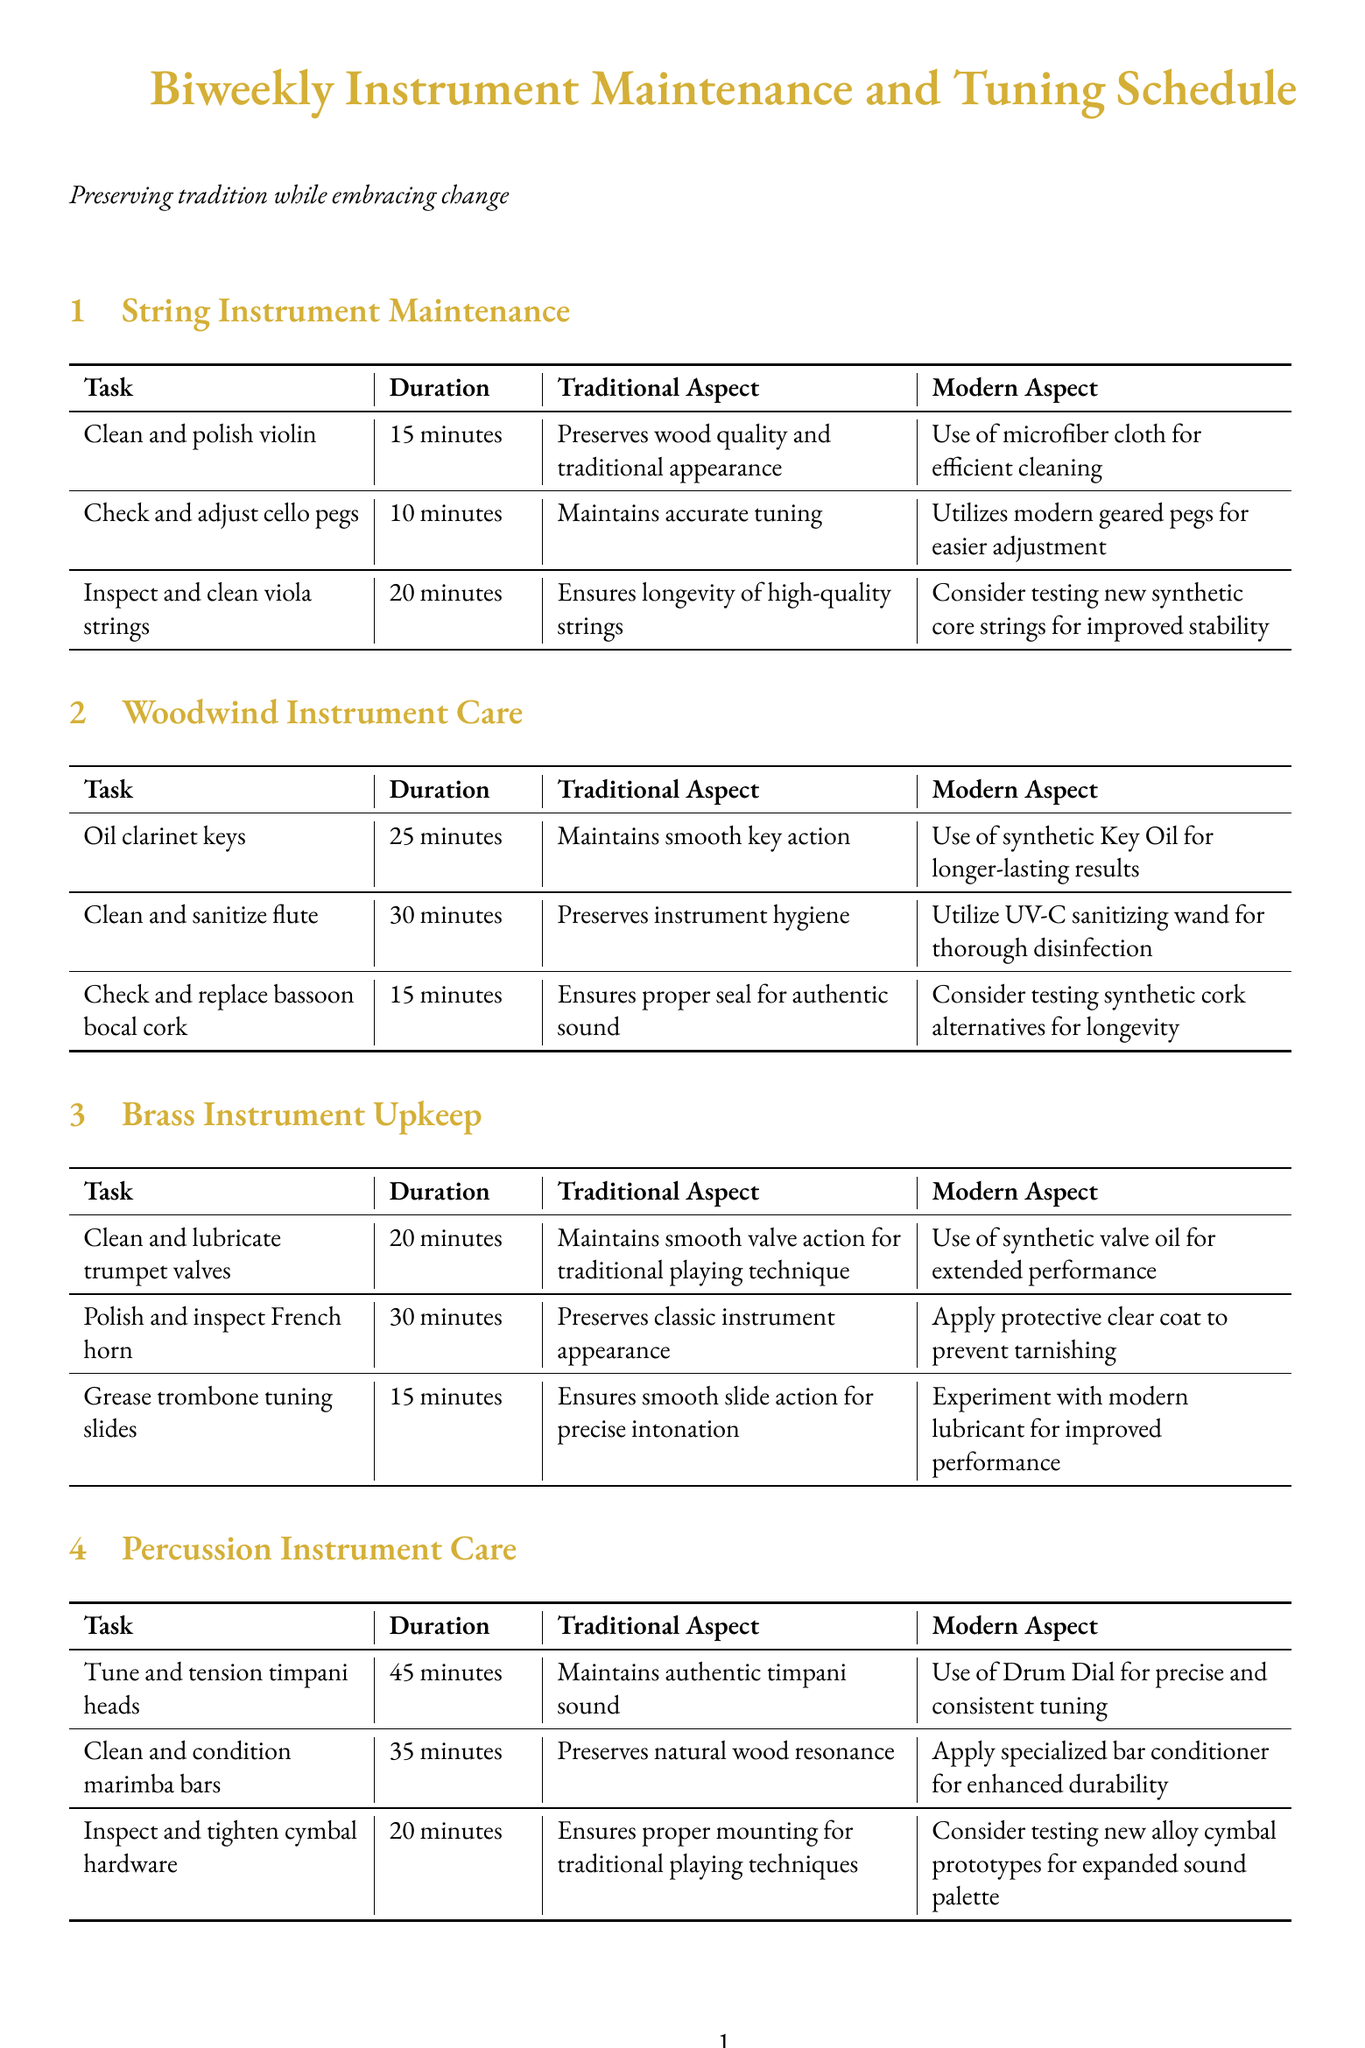What is the duration for cleaning and polishing the violin? The task of cleaning and polishing the violin takes 15 minutes as indicated in the schedule.
Answer: 15 minutes How often is the woodwind instrument care scheduled? The document states that woodwind instrument care is scheduled biweekly, as mentioned in the frequency section.
Answer: Biweekly What modern aspect is used for cleaning and sanitizing the flute? The use of a UV-C sanitizing wand for thorough disinfection is mentioned as the modern aspect for cleaning and sanitizing the flute.
Answer: UV-C sanitizing wand Which brass instrument requires greasing of tuning slides? The task mentions that greasing tuning slides is required for the Edwards tenor trombone, referring to specific maintenance for that instrument.
Answer: Edwards tenor trombone What traditional aspect is preserved when tuning the Steinway & Sons concert grand piano? The traditional aspect preserved is maintaining precise pitch for classical repertoire, as detailed in the piano maintenance section.
Answer: Maintains precise pitch for classical repertoire What modern technology is utilized in the Active Field Control system? The document indicates that digital signal processing is utilized for optimal sound in the Active Field Control system.
Answer: Digital signal processing Which instrument is inspected for hardware tightening in the percussion section? The Zildjian symphonic cymbals are noted for inspection and tightening of hardware.
Answer: Zildjian symphonic cymbals How long does it take to tune the timpani heads? Tuning and tensioning the timpani heads takes 45 minutes as listed in the maintenance schedule.
Answer: 45 minutes 